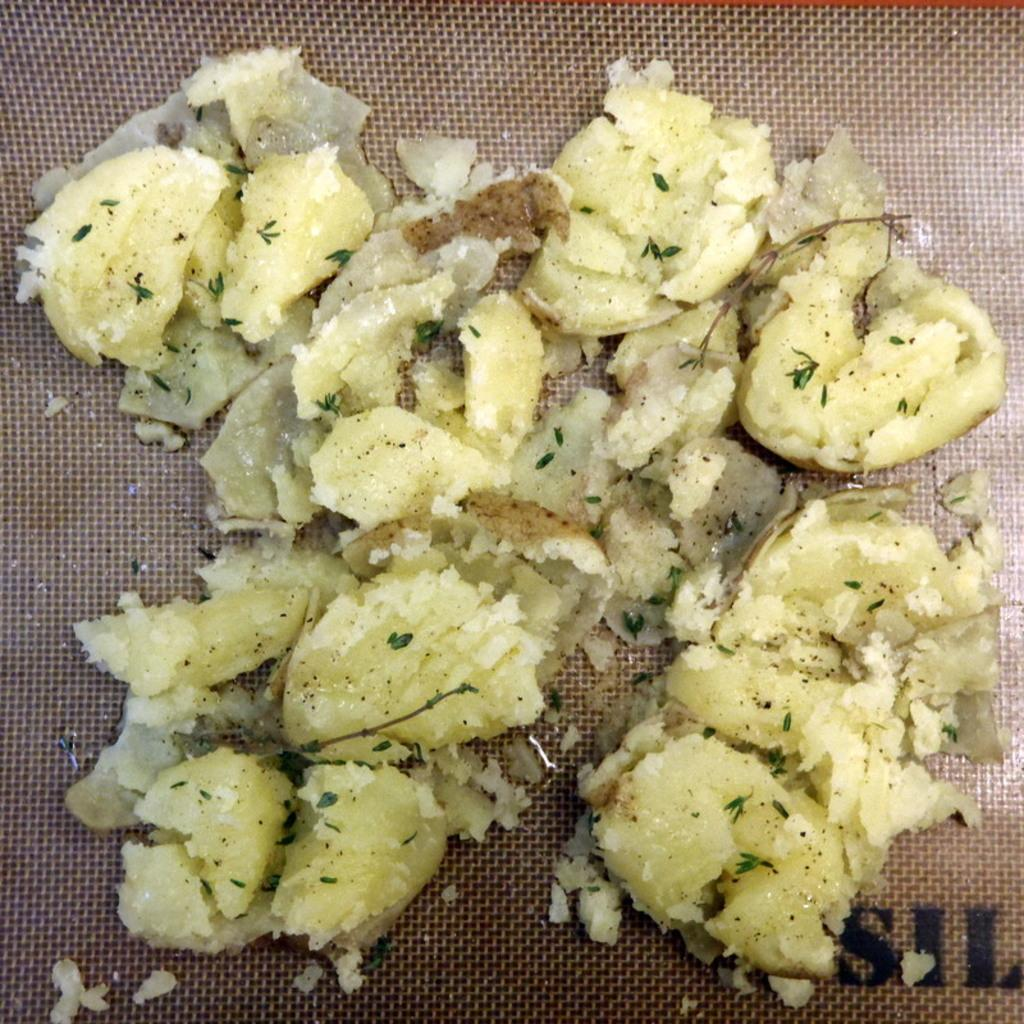What type of items are present in the image? There are eatables in the image. Where are the eatables placed? The eatables are placed on an object. How many girls are present in the image? There is no mention of girls in the provided facts, so we cannot determine the number of girls in the image. What type of material is the object made of? The provided facts do not specify the material of the object, so we cannot determine the material. 